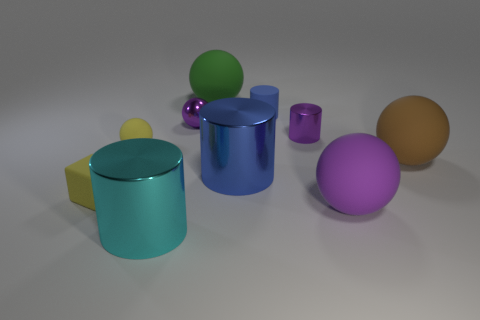Subtract all green balls. How many balls are left? 4 Subtract all green rubber balls. How many balls are left? 4 Subtract 2 spheres. How many spheres are left? 3 Subtract all blue spheres. Subtract all gray blocks. How many spheres are left? 5 Subtract all cubes. How many objects are left? 9 Subtract all matte cubes. Subtract all tiny blocks. How many objects are left? 8 Add 5 big matte spheres. How many big matte spheres are left? 8 Add 9 small yellow shiny cylinders. How many small yellow shiny cylinders exist? 9 Subtract 0 cyan blocks. How many objects are left? 10 